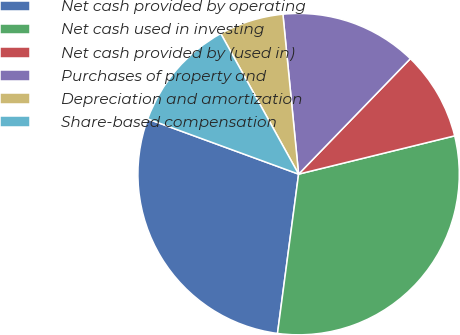Convert chart. <chart><loc_0><loc_0><loc_500><loc_500><pie_chart><fcel>Net cash provided by operating<fcel>Net cash used in investing<fcel>Net cash provided by (used in)<fcel>Purchases of property and<fcel>Depreciation and amortization<fcel>Share-based compensation<nl><fcel>28.49%<fcel>30.93%<fcel>8.93%<fcel>13.8%<fcel>6.49%<fcel>11.37%<nl></chart> 